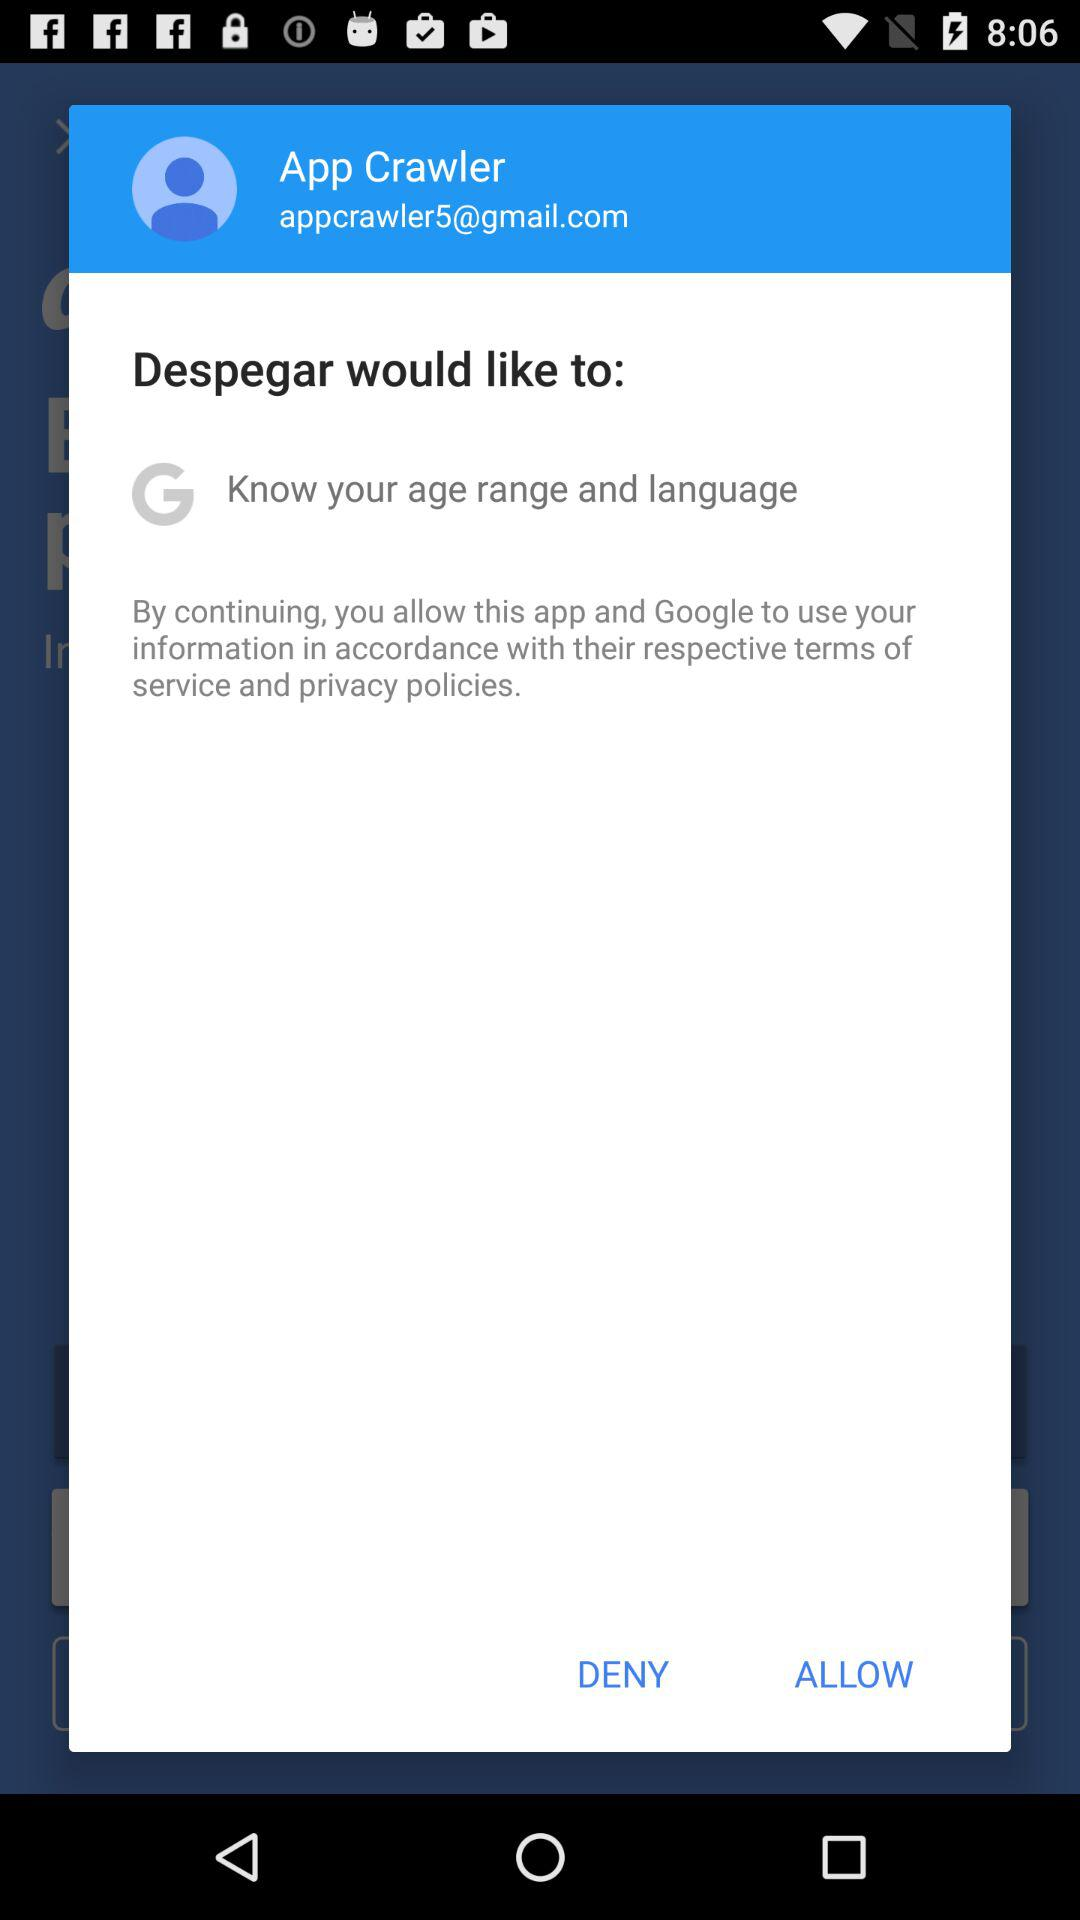What is the email address of the user? The email address of the user is appcrawler5@gmail.com. 